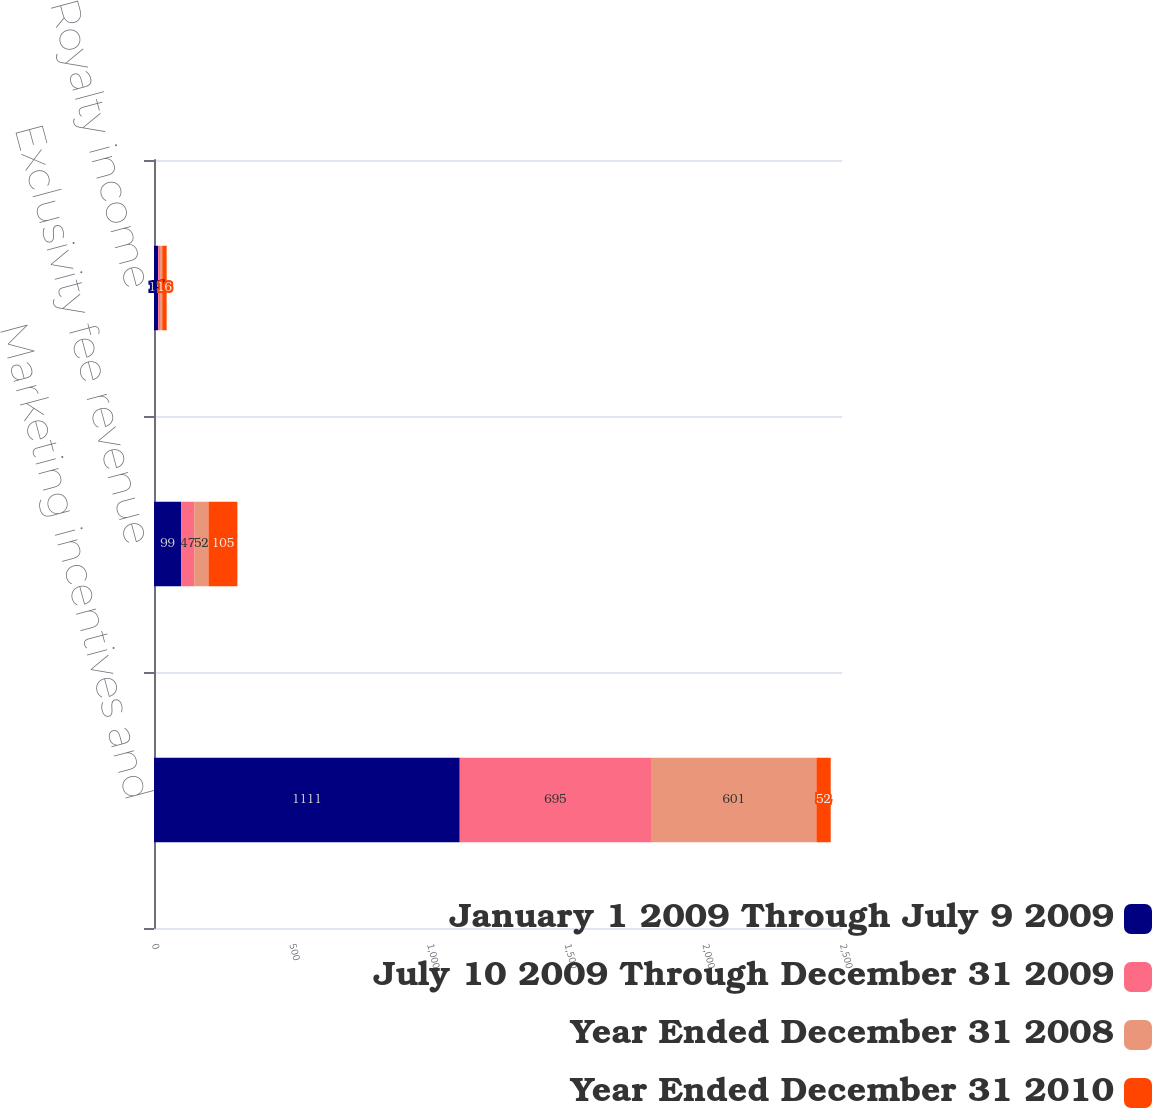Convert chart to OTSL. <chart><loc_0><loc_0><loc_500><loc_500><stacked_bar_chart><ecel><fcel>Marketing incentives and<fcel>Exclusivity fee revenue<fcel>Royalty income<nl><fcel>January 1 2009 Through July 9 2009<fcel>1111<fcel>99<fcel>15<nl><fcel>July 10 2009 Through December 31 2009<fcel>695<fcel>47<fcel>7<nl><fcel>Year Ended December 31 2008<fcel>601<fcel>52<fcel>8<nl><fcel>Year Ended December 31 2010<fcel>52<fcel>105<fcel>16<nl></chart> 